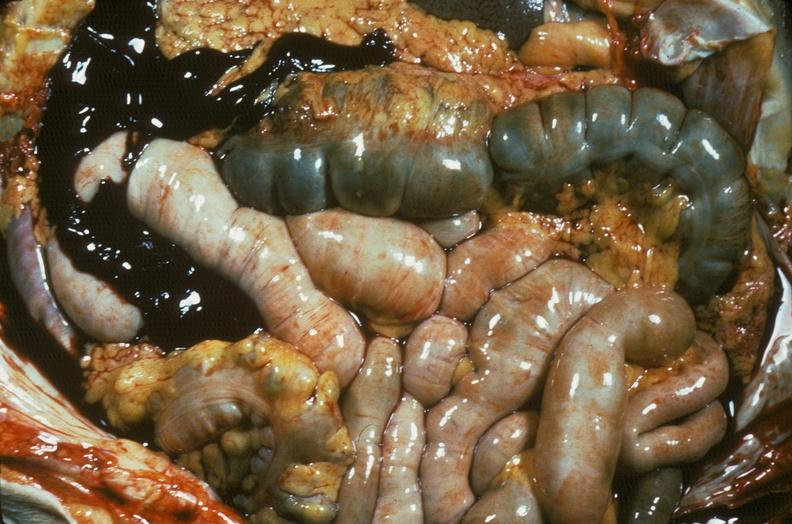what is present?
Answer the question using a single word or phrase. Abdomen 